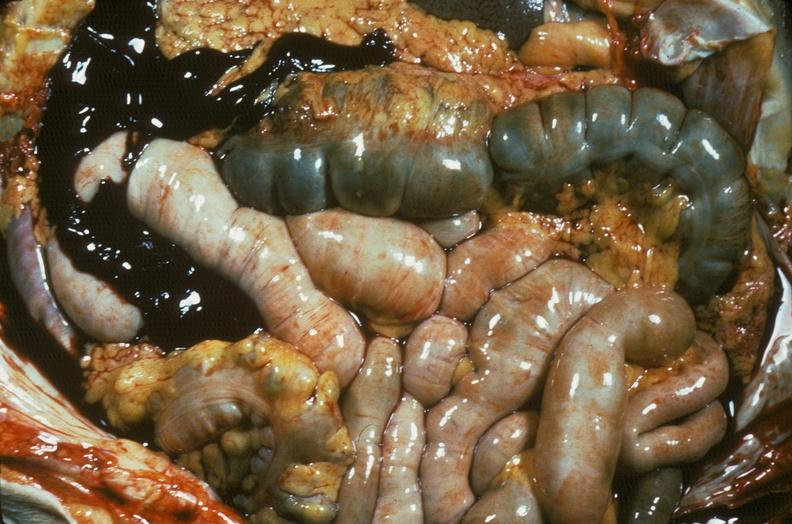what is present?
Answer the question using a single word or phrase. Abdomen 